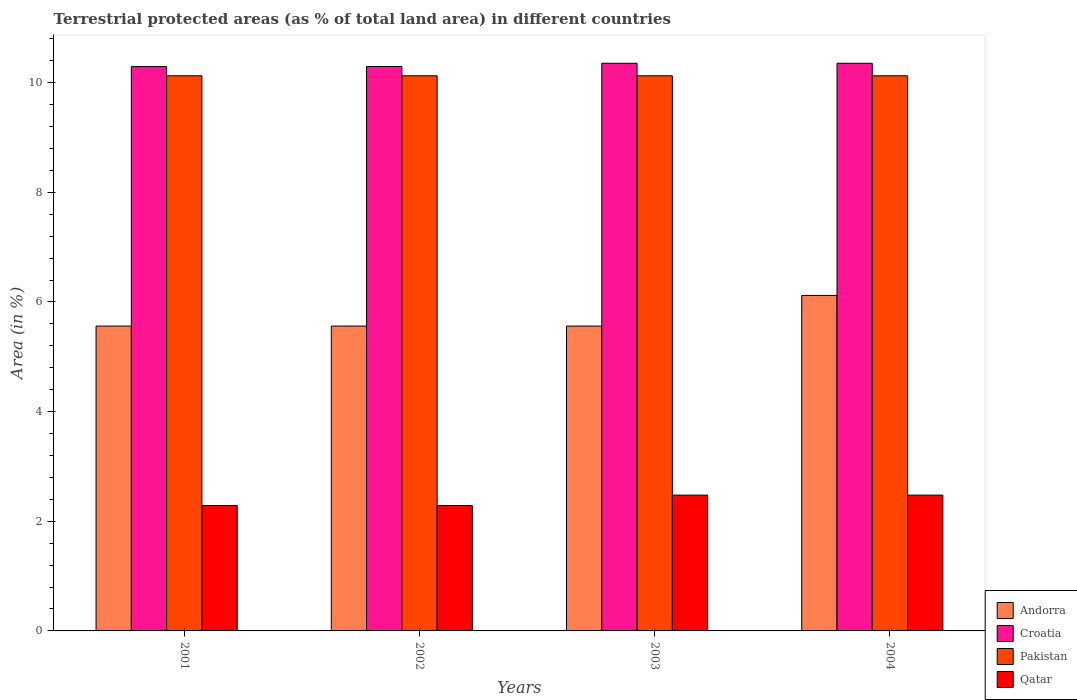How many groups of bars are there?
Ensure brevity in your answer.  4. Are the number of bars per tick equal to the number of legend labels?
Give a very brief answer. Yes. What is the label of the 3rd group of bars from the left?
Your answer should be very brief. 2003. What is the percentage of terrestrial protected land in Qatar in 2004?
Offer a terse response. 2.48. Across all years, what is the maximum percentage of terrestrial protected land in Croatia?
Keep it short and to the point. 10.35. Across all years, what is the minimum percentage of terrestrial protected land in Croatia?
Give a very brief answer. 10.29. In which year was the percentage of terrestrial protected land in Pakistan maximum?
Your answer should be very brief. 2001. In which year was the percentage of terrestrial protected land in Pakistan minimum?
Keep it short and to the point. 2001. What is the total percentage of terrestrial protected land in Qatar in the graph?
Your answer should be compact. 9.53. What is the difference between the percentage of terrestrial protected land in Andorra in 2003 and that in 2004?
Your response must be concise. -0.56. What is the difference between the percentage of terrestrial protected land in Qatar in 2001 and the percentage of terrestrial protected land in Andorra in 2002?
Your answer should be very brief. -3.27. What is the average percentage of terrestrial protected land in Andorra per year?
Keep it short and to the point. 5.7. In the year 2002, what is the difference between the percentage of terrestrial protected land in Croatia and percentage of terrestrial protected land in Pakistan?
Your answer should be very brief. 0.17. In how many years, is the percentage of terrestrial protected land in Croatia greater than 9.6 %?
Keep it short and to the point. 4. What is the ratio of the percentage of terrestrial protected land in Pakistan in 2001 to that in 2003?
Offer a terse response. 1. Is the difference between the percentage of terrestrial protected land in Croatia in 2001 and 2004 greater than the difference between the percentage of terrestrial protected land in Pakistan in 2001 and 2004?
Your response must be concise. No. What is the difference between the highest and the lowest percentage of terrestrial protected land in Croatia?
Your response must be concise. 0.06. In how many years, is the percentage of terrestrial protected land in Andorra greater than the average percentage of terrestrial protected land in Andorra taken over all years?
Offer a terse response. 1. Is it the case that in every year, the sum of the percentage of terrestrial protected land in Andorra and percentage of terrestrial protected land in Qatar is greater than the sum of percentage of terrestrial protected land in Pakistan and percentage of terrestrial protected land in Croatia?
Provide a short and direct response. No. What does the 3rd bar from the left in 2001 represents?
Your answer should be compact. Pakistan. What does the 3rd bar from the right in 2002 represents?
Provide a succinct answer. Croatia. How many bars are there?
Your answer should be very brief. 16. How many years are there in the graph?
Make the answer very short. 4. What is the difference between two consecutive major ticks on the Y-axis?
Provide a short and direct response. 2. Are the values on the major ticks of Y-axis written in scientific E-notation?
Give a very brief answer. No. Where does the legend appear in the graph?
Provide a short and direct response. Bottom right. How many legend labels are there?
Your answer should be very brief. 4. How are the legend labels stacked?
Make the answer very short. Vertical. What is the title of the graph?
Provide a short and direct response. Terrestrial protected areas (as % of total land area) in different countries. Does "Switzerland" appear as one of the legend labels in the graph?
Your answer should be very brief. No. What is the label or title of the Y-axis?
Keep it short and to the point. Area (in %). What is the Area (in %) in Andorra in 2001?
Provide a succinct answer. 5.56. What is the Area (in %) in Croatia in 2001?
Offer a terse response. 10.29. What is the Area (in %) of Pakistan in 2001?
Offer a very short reply. 10.13. What is the Area (in %) in Qatar in 2001?
Offer a very short reply. 2.29. What is the Area (in %) in Andorra in 2002?
Provide a short and direct response. 5.56. What is the Area (in %) in Croatia in 2002?
Your answer should be compact. 10.29. What is the Area (in %) in Pakistan in 2002?
Your answer should be very brief. 10.13. What is the Area (in %) in Qatar in 2002?
Provide a succinct answer. 2.29. What is the Area (in %) in Andorra in 2003?
Offer a terse response. 5.56. What is the Area (in %) of Croatia in 2003?
Give a very brief answer. 10.35. What is the Area (in %) of Pakistan in 2003?
Your answer should be very brief. 10.13. What is the Area (in %) of Qatar in 2003?
Ensure brevity in your answer.  2.48. What is the Area (in %) in Andorra in 2004?
Provide a succinct answer. 6.12. What is the Area (in %) of Croatia in 2004?
Make the answer very short. 10.35. What is the Area (in %) in Pakistan in 2004?
Offer a very short reply. 10.13. What is the Area (in %) in Qatar in 2004?
Ensure brevity in your answer.  2.48. Across all years, what is the maximum Area (in %) in Andorra?
Offer a terse response. 6.12. Across all years, what is the maximum Area (in %) of Croatia?
Keep it short and to the point. 10.35. Across all years, what is the maximum Area (in %) of Pakistan?
Your answer should be very brief. 10.13. Across all years, what is the maximum Area (in %) of Qatar?
Your answer should be compact. 2.48. Across all years, what is the minimum Area (in %) of Andorra?
Your answer should be compact. 5.56. Across all years, what is the minimum Area (in %) in Croatia?
Your answer should be compact. 10.29. Across all years, what is the minimum Area (in %) in Pakistan?
Make the answer very short. 10.13. Across all years, what is the minimum Area (in %) in Qatar?
Provide a short and direct response. 2.29. What is the total Area (in %) in Andorra in the graph?
Your response must be concise. 22.8. What is the total Area (in %) of Croatia in the graph?
Make the answer very short. 41.3. What is the total Area (in %) of Pakistan in the graph?
Provide a succinct answer. 40.5. What is the total Area (in %) of Qatar in the graph?
Offer a very short reply. 9.53. What is the difference between the Area (in %) in Andorra in 2001 and that in 2002?
Provide a short and direct response. 0. What is the difference between the Area (in %) in Croatia in 2001 and that in 2002?
Your response must be concise. -0. What is the difference between the Area (in %) in Croatia in 2001 and that in 2003?
Offer a terse response. -0.06. What is the difference between the Area (in %) in Qatar in 2001 and that in 2003?
Provide a short and direct response. -0.19. What is the difference between the Area (in %) of Andorra in 2001 and that in 2004?
Your answer should be very brief. -0.56. What is the difference between the Area (in %) in Croatia in 2001 and that in 2004?
Your answer should be compact. -0.06. What is the difference between the Area (in %) in Qatar in 2001 and that in 2004?
Give a very brief answer. -0.19. What is the difference between the Area (in %) in Andorra in 2002 and that in 2003?
Make the answer very short. 0. What is the difference between the Area (in %) of Croatia in 2002 and that in 2003?
Keep it short and to the point. -0.06. What is the difference between the Area (in %) in Pakistan in 2002 and that in 2003?
Your response must be concise. 0. What is the difference between the Area (in %) in Qatar in 2002 and that in 2003?
Provide a short and direct response. -0.19. What is the difference between the Area (in %) in Andorra in 2002 and that in 2004?
Ensure brevity in your answer.  -0.56. What is the difference between the Area (in %) in Croatia in 2002 and that in 2004?
Offer a terse response. -0.06. What is the difference between the Area (in %) of Qatar in 2002 and that in 2004?
Offer a terse response. -0.19. What is the difference between the Area (in %) of Andorra in 2003 and that in 2004?
Keep it short and to the point. -0.56. What is the difference between the Area (in %) in Pakistan in 2003 and that in 2004?
Provide a short and direct response. 0. What is the difference between the Area (in %) in Qatar in 2003 and that in 2004?
Your answer should be compact. 0. What is the difference between the Area (in %) in Andorra in 2001 and the Area (in %) in Croatia in 2002?
Provide a short and direct response. -4.73. What is the difference between the Area (in %) of Andorra in 2001 and the Area (in %) of Pakistan in 2002?
Ensure brevity in your answer.  -4.57. What is the difference between the Area (in %) in Andorra in 2001 and the Area (in %) in Qatar in 2002?
Provide a short and direct response. 3.27. What is the difference between the Area (in %) of Croatia in 2001 and the Area (in %) of Pakistan in 2002?
Ensure brevity in your answer.  0.17. What is the difference between the Area (in %) of Croatia in 2001 and the Area (in %) of Qatar in 2002?
Keep it short and to the point. 8.01. What is the difference between the Area (in %) of Pakistan in 2001 and the Area (in %) of Qatar in 2002?
Your answer should be compact. 7.84. What is the difference between the Area (in %) of Andorra in 2001 and the Area (in %) of Croatia in 2003?
Keep it short and to the point. -4.79. What is the difference between the Area (in %) in Andorra in 2001 and the Area (in %) in Pakistan in 2003?
Your answer should be very brief. -4.57. What is the difference between the Area (in %) of Andorra in 2001 and the Area (in %) of Qatar in 2003?
Provide a short and direct response. 3.08. What is the difference between the Area (in %) of Croatia in 2001 and the Area (in %) of Pakistan in 2003?
Your answer should be very brief. 0.17. What is the difference between the Area (in %) in Croatia in 2001 and the Area (in %) in Qatar in 2003?
Your answer should be compact. 7.82. What is the difference between the Area (in %) in Pakistan in 2001 and the Area (in %) in Qatar in 2003?
Your response must be concise. 7.65. What is the difference between the Area (in %) in Andorra in 2001 and the Area (in %) in Croatia in 2004?
Provide a short and direct response. -4.79. What is the difference between the Area (in %) in Andorra in 2001 and the Area (in %) in Pakistan in 2004?
Offer a terse response. -4.57. What is the difference between the Area (in %) of Andorra in 2001 and the Area (in %) of Qatar in 2004?
Give a very brief answer. 3.08. What is the difference between the Area (in %) of Croatia in 2001 and the Area (in %) of Pakistan in 2004?
Offer a terse response. 0.17. What is the difference between the Area (in %) of Croatia in 2001 and the Area (in %) of Qatar in 2004?
Offer a very short reply. 7.82. What is the difference between the Area (in %) in Pakistan in 2001 and the Area (in %) in Qatar in 2004?
Offer a very short reply. 7.65. What is the difference between the Area (in %) in Andorra in 2002 and the Area (in %) in Croatia in 2003?
Your response must be concise. -4.79. What is the difference between the Area (in %) of Andorra in 2002 and the Area (in %) of Pakistan in 2003?
Your response must be concise. -4.57. What is the difference between the Area (in %) in Andorra in 2002 and the Area (in %) in Qatar in 2003?
Keep it short and to the point. 3.08. What is the difference between the Area (in %) of Croatia in 2002 and the Area (in %) of Pakistan in 2003?
Keep it short and to the point. 0.17. What is the difference between the Area (in %) of Croatia in 2002 and the Area (in %) of Qatar in 2003?
Provide a succinct answer. 7.82. What is the difference between the Area (in %) of Pakistan in 2002 and the Area (in %) of Qatar in 2003?
Ensure brevity in your answer.  7.65. What is the difference between the Area (in %) of Andorra in 2002 and the Area (in %) of Croatia in 2004?
Offer a very short reply. -4.79. What is the difference between the Area (in %) in Andorra in 2002 and the Area (in %) in Pakistan in 2004?
Provide a short and direct response. -4.57. What is the difference between the Area (in %) in Andorra in 2002 and the Area (in %) in Qatar in 2004?
Give a very brief answer. 3.08. What is the difference between the Area (in %) in Croatia in 2002 and the Area (in %) in Pakistan in 2004?
Keep it short and to the point. 0.17. What is the difference between the Area (in %) of Croatia in 2002 and the Area (in %) of Qatar in 2004?
Your answer should be very brief. 7.82. What is the difference between the Area (in %) in Pakistan in 2002 and the Area (in %) in Qatar in 2004?
Your response must be concise. 7.65. What is the difference between the Area (in %) of Andorra in 2003 and the Area (in %) of Croatia in 2004?
Ensure brevity in your answer.  -4.79. What is the difference between the Area (in %) in Andorra in 2003 and the Area (in %) in Pakistan in 2004?
Keep it short and to the point. -4.57. What is the difference between the Area (in %) in Andorra in 2003 and the Area (in %) in Qatar in 2004?
Provide a short and direct response. 3.08. What is the difference between the Area (in %) of Croatia in 2003 and the Area (in %) of Pakistan in 2004?
Your response must be concise. 0.23. What is the difference between the Area (in %) in Croatia in 2003 and the Area (in %) in Qatar in 2004?
Make the answer very short. 7.88. What is the difference between the Area (in %) of Pakistan in 2003 and the Area (in %) of Qatar in 2004?
Your answer should be very brief. 7.65. What is the average Area (in %) of Andorra per year?
Your answer should be compact. 5.7. What is the average Area (in %) of Croatia per year?
Provide a short and direct response. 10.32. What is the average Area (in %) of Pakistan per year?
Your answer should be very brief. 10.13. What is the average Area (in %) of Qatar per year?
Your answer should be very brief. 2.38. In the year 2001, what is the difference between the Area (in %) of Andorra and Area (in %) of Croatia?
Provide a succinct answer. -4.73. In the year 2001, what is the difference between the Area (in %) in Andorra and Area (in %) in Pakistan?
Offer a very short reply. -4.57. In the year 2001, what is the difference between the Area (in %) of Andorra and Area (in %) of Qatar?
Give a very brief answer. 3.27. In the year 2001, what is the difference between the Area (in %) of Croatia and Area (in %) of Pakistan?
Your answer should be very brief. 0.17. In the year 2001, what is the difference between the Area (in %) of Croatia and Area (in %) of Qatar?
Offer a terse response. 8.01. In the year 2001, what is the difference between the Area (in %) in Pakistan and Area (in %) in Qatar?
Provide a short and direct response. 7.84. In the year 2002, what is the difference between the Area (in %) in Andorra and Area (in %) in Croatia?
Offer a very short reply. -4.73. In the year 2002, what is the difference between the Area (in %) of Andorra and Area (in %) of Pakistan?
Keep it short and to the point. -4.57. In the year 2002, what is the difference between the Area (in %) in Andorra and Area (in %) in Qatar?
Provide a succinct answer. 3.27. In the year 2002, what is the difference between the Area (in %) of Croatia and Area (in %) of Pakistan?
Your answer should be compact. 0.17. In the year 2002, what is the difference between the Area (in %) of Croatia and Area (in %) of Qatar?
Give a very brief answer. 8.01. In the year 2002, what is the difference between the Area (in %) of Pakistan and Area (in %) of Qatar?
Provide a short and direct response. 7.84. In the year 2003, what is the difference between the Area (in %) of Andorra and Area (in %) of Croatia?
Make the answer very short. -4.79. In the year 2003, what is the difference between the Area (in %) in Andorra and Area (in %) in Pakistan?
Ensure brevity in your answer.  -4.57. In the year 2003, what is the difference between the Area (in %) of Andorra and Area (in %) of Qatar?
Give a very brief answer. 3.08. In the year 2003, what is the difference between the Area (in %) of Croatia and Area (in %) of Pakistan?
Your answer should be very brief. 0.23. In the year 2003, what is the difference between the Area (in %) of Croatia and Area (in %) of Qatar?
Your response must be concise. 7.88. In the year 2003, what is the difference between the Area (in %) in Pakistan and Area (in %) in Qatar?
Keep it short and to the point. 7.65. In the year 2004, what is the difference between the Area (in %) of Andorra and Area (in %) of Croatia?
Provide a succinct answer. -4.23. In the year 2004, what is the difference between the Area (in %) of Andorra and Area (in %) of Pakistan?
Keep it short and to the point. -4.01. In the year 2004, what is the difference between the Area (in %) in Andorra and Area (in %) in Qatar?
Offer a terse response. 3.64. In the year 2004, what is the difference between the Area (in %) in Croatia and Area (in %) in Pakistan?
Offer a terse response. 0.23. In the year 2004, what is the difference between the Area (in %) in Croatia and Area (in %) in Qatar?
Make the answer very short. 7.88. In the year 2004, what is the difference between the Area (in %) in Pakistan and Area (in %) in Qatar?
Provide a succinct answer. 7.65. What is the ratio of the Area (in %) of Croatia in 2001 to that in 2002?
Your answer should be very brief. 1. What is the ratio of the Area (in %) in Pakistan in 2001 to that in 2002?
Make the answer very short. 1. What is the ratio of the Area (in %) in Qatar in 2001 to that in 2003?
Provide a short and direct response. 0.92. What is the ratio of the Area (in %) in Andorra in 2001 to that in 2004?
Your answer should be very brief. 0.91. What is the ratio of the Area (in %) in Croatia in 2001 to that in 2004?
Your answer should be very brief. 0.99. What is the ratio of the Area (in %) of Qatar in 2001 to that in 2004?
Provide a short and direct response. 0.92. What is the ratio of the Area (in %) of Croatia in 2002 to that in 2003?
Your answer should be compact. 0.99. What is the ratio of the Area (in %) in Pakistan in 2002 to that in 2003?
Ensure brevity in your answer.  1. What is the ratio of the Area (in %) of Qatar in 2002 to that in 2003?
Offer a terse response. 0.92. What is the ratio of the Area (in %) of Andorra in 2002 to that in 2004?
Offer a very short reply. 0.91. What is the ratio of the Area (in %) in Pakistan in 2002 to that in 2004?
Your answer should be very brief. 1. What is the ratio of the Area (in %) of Qatar in 2002 to that in 2004?
Your response must be concise. 0.92. What is the ratio of the Area (in %) of Andorra in 2003 to that in 2004?
Give a very brief answer. 0.91. What is the ratio of the Area (in %) in Qatar in 2003 to that in 2004?
Your response must be concise. 1. What is the difference between the highest and the second highest Area (in %) in Andorra?
Keep it short and to the point. 0.56. What is the difference between the highest and the second highest Area (in %) of Qatar?
Offer a terse response. 0. What is the difference between the highest and the lowest Area (in %) of Andorra?
Your response must be concise. 0.56. What is the difference between the highest and the lowest Area (in %) of Croatia?
Your response must be concise. 0.06. What is the difference between the highest and the lowest Area (in %) in Qatar?
Provide a succinct answer. 0.19. 